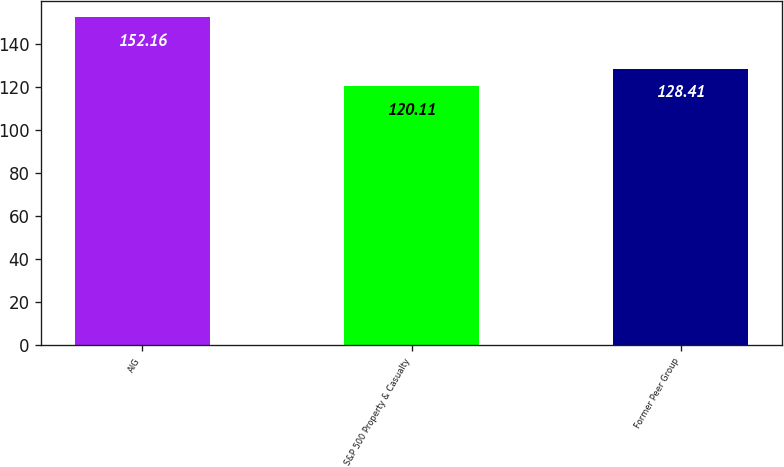<chart> <loc_0><loc_0><loc_500><loc_500><bar_chart><fcel>AIG<fcel>S&P 500 Property & Casualty<fcel>Former Peer Group<nl><fcel>152.16<fcel>120.11<fcel>128.41<nl></chart> 